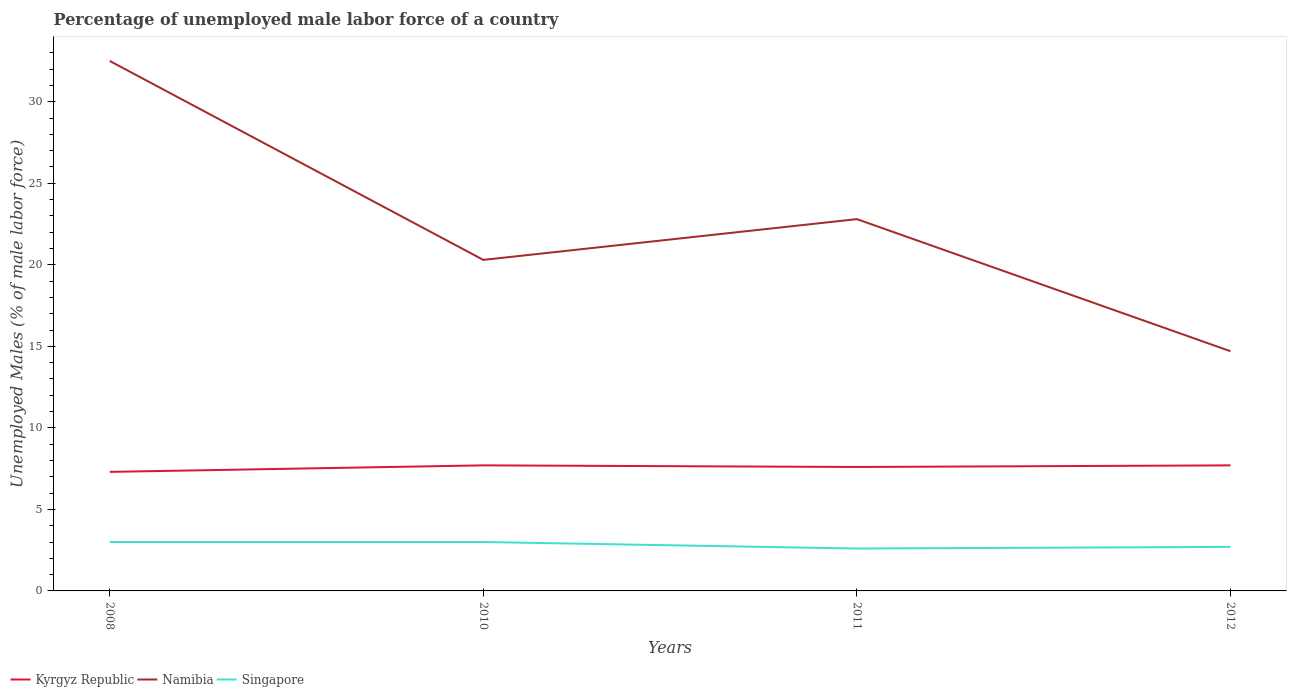Is the number of lines equal to the number of legend labels?
Your response must be concise. Yes. Across all years, what is the maximum percentage of unemployed male labor force in Kyrgyz Republic?
Give a very brief answer. 7.3. In which year was the percentage of unemployed male labor force in Namibia maximum?
Make the answer very short. 2012. What is the total percentage of unemployed male labor force in Namibia in the graph?
Give a very brief answer. -2.5. What is the difference between the highest and the second highest percentage of unemployed male labor force in Kyrgyz Republic?
Make the answer very short. 0.4. Is the percentage of unemployed male labor force in Kyrgyz Republic strictly greater than the percentage of unemployed male labor force in Namibia over the years?
Keep it short and to the point. Yes. How many years are there in the graph?
Ensure brevity in your answer.  4. Where does the legend appear in the graph?
Your response must be concise. Bottom left. How many legend labels are there?
Provide a succinct answer. 3. How are the legend labels stacked?
Keep it short and to the point. Horizontal. What is the title of the graph?
Give a very brief answer. Percentage of unemployed male labor force of a country. What is the label or title of the X-axis?
Offer a terse response. Years. What is the label or title of the Y-axis?
Your response must be concise. Unemployed Males (% of male labor force). What is the Unemployed Males (% of male labor force) in Kyrgyz Republic in 2008?
Make the answer very short. 7.3. What is the Unemployed Males (% of male labor force) of Namibia in 2008?
Your answer should be very brief. 32.5. What is the Unemployed Males (% of male labor force) of Singapore in 2008?
Make the answer very short. 3. What is the Unemployed Males (% of male labor force) of Kyrgyz Republic in 2010?
Provide a succinct answer. 7.7. What is the Unemployed Males (% of male labor force) in Namibia in 2010?
Provide a short and direct response. 20.3. What is the Unemployed Males (% of male labor force) in Kyrgyz Republic in 2011?
Provide a succinct answer. 7.6. What is the Unemployed Males (% of male labor force) of Namibia in 2011?
Offer a very short reply. 22.8. What is the Unemployed Males (% of male labor force) in Singapore in 2011?
Your answer should be very brief. 2.6. What is the Unemployed Males (% of male labor force) in Kyrgyz Republic in 2012?
Keep it short and to the point. 7.7. What is the Unemployed Males (% of male labor force) in Namibia in 2012?
Provide a short and direct response. 14.7. What is the Unemployed Males (% of male labor force) in Singapore in 2012?
Offer a very short reply. 2.7. Across all years, what is the maximum Unemployed Males (% of male labor force) of Kyrgyz Republic?
Ensure brevity in your answer.  7.7. Across all years, what is the maximum Unemployed Males (% of male labor force) of Namibia?
Offer a very short reply. 32.5. Across all years, what is the maximum Unemployed Males (% of male labor force) in Singapore?
Make the answer very short. 3. Across all years, what is the minimum Unemployed Males (% of male labor force) of Kyrgyz Republic?
Your answer should be compact. 7.3. Across all years, what is the minimum Unemployed Males (% of male labor force) in Namibia?
Give a very brief answer. 14.7. Across all years, what is the minimum Unemployed Males (% of male labor force) in Singapore?
Give a very brief answer. 2.6. What is the total Unemployed Males (% of male labor force) of Kyrgyz Republic in the graph?
Ensure brevity in your answer.  30.3. What is the total Unemployed Males (% of male labor force) in Namibia in the graph?
Your answer should be compact. 90.3. What is the total Unemployed Males (% of male labor force) of Singapore in the graph?
Ensure brevity in your answer.  11.3. What is the difference between the Unemployed Males (% of male labor force) of Kyrgyz Republic in 2008 and that in 2010?
Your response must be concise. -0.4. What is the difference between the Unemployed Males (% of male labor force) in Singapore in 2008 and that in 2011?
Give a very brief answer. 0.4. What is the difference between the Unemployed Males (% of male labor force) of Kyrgyz Republic in 2008 and that in 2012?
Make the answer very short. -0.4. What is the difference between the Unemployed Males (% of male labor force) of Singapore in 2008 and that in 2012?
Keep it short and to the point. 0.3. What is the difference between the Unemployed Males (% of male labor force) of Namibia in 2010 and that in 2011?
Your response must be concise. -2.5. What is the difference between the Unemployed Males (% of male labor force) in Kyrgyz Republic in 2010 and that in 2012?
Make the answer very short. 0. What is the difference between the Unemployed Males (% of male labor force) in Namibia in 2010 and that in 2012?
Offer a very short reply. 5.6. What is the difference between the Unemployed Males (% of male labor force) of Singapore in 2010 and that in 2012?
Your answer should be compact. 0.3. What is the difference between the Unemployed Males (% of male labor force) of Singapore in 2011 and that in 2012?
Provide a succinct answer. -0.1. What is the difference between the Unemployed Males (% of male labor force) of Kyrgyz Republic in 2008 and the Unemployed Males (% of male labor force) of Namibia in 2010?
Make the answer very short. -13. What is the difference between the Unemployed Males (% of male labor force) of Kyrgyz Republic in 2008 and the Unemployed Males (% of male labor force) of Singapore in 2010?
Provide a short and direct response. 4.3. What is the difference between the Unemployed Males (% of male labor force) of Namibia in 2008 and the Unemployed Males (% of male labor force) of Singapore in 2010?
Your response must be concise. 29.5. What is the difference between the Unemployed Males (% of male labor force) of Kyrgyz Republic in 2008 and the Unemployed Males (% of male labor force) of Namibia in 2011?
Keep it short and to the point. -15.5. What is the difference between the Unemployed Males (% of male labor force) of Namibia in 2008 and the Unemployed Males (% of male labor force) of Singapore in 2011?
Keep it short and to the point. 29.9. What is the difference between the Unemployed Males (% of male labor force) of Kyrgyz Republic in 2008 and the Unemployed Males (% of male labor force) of Namibia in 2012?
Your answer should be compact. -7.4. What is the difference between the Unemployed Males (% of male labor force) in Kyrgyz Republic in 2008 and the Unemployed Males (% of male labor force) in Singapore in 2012?
Your answer should be compact. 4.6. What is the difference between the Unemployed Males (% of male labor force) of Namibia in 2008 and the Unemployed Males (% of male labor force) of Singapore in 2012?
Your response must be concise. 29.8. What is the difference between the Unemployed Males (% of male labor force) in Kyrgyz Republic in 2010 and the Unemployed Males (% of male labor force) in Namibia in 2011?
Offer a terse response. -15.1. What is the difference between the Unemployed Males (% of male labor force) in Kyrgyz Republic in 2010 and the Unemployed Males (% of male labor force) in Singapore in 2012?
Make the answer very short. 5. What is the difference between the Unemployed Males (% of male labor force) of Namibia in 2010 and the Unemployed Males (% of male labor force) of Singapore in 2012?
Ensure brevity in your answer.  17.6. What is the difference between the Unemployed Males (% of male labor force) in Kyrgyz Republic in 2011 and the Unemployed Males (% of male labor force) in Namibia in 2012?
Make the answer very short. -7.1. What is the difference between the Unemployed Males (% of male labor force) in Namibia in 2011 and the Unemployed Males (% of male labor force) in Singapore in 2012?
Ensure brevity in your answer.  20.1. What is the average Unemployed Males (% of male labor force) in Kyrgyz Republic per year?
Provide a short and direct response. 7.58. What is the average Unemployed Males (% of male labor force) in Namibia per year?
Your response must be concise. 22.57. What is the average Unemployed Males (% of male labor force) in Singapore per year?
Provide a short and direct response. 2.83. In the year 2008, what is the difference between the Unemployed Males (% of male labor force) of Kyrgyz Republic and Unemployed Males (% of male labor force) of Namibia?
Your answer should be compact. -25.2. In the year 2008, what is the difference between the Unemployed Males (% of male labor force) of Kyrgyz Republic and Unemployed Males (% of male labor force) of Singapore?
Keep it short and to the point. 4.3. In the year 2008, what is the difference between the Unemployed Males (% of male labor force) in Namibia and Unemployed Males (% of male labor force) in Singapore?
Give a very brief answer. 29.5. In the year 2010, what is the difference between the Unemployed Males (% of male labor force) of Kyrgyz Republic and Unemployed Males (% of male labor force) of Namibia?
Provide a succinct answer. -12.6. In the year 2011, what is the difference between the Unemployed Males (% of male labor force) of Kyrgyz Republic and Unemployed Males (% of male labor force) of Namibia?
Give a very brief answer. -15.2. In the year 2011, what is the difference between the Unemployed Males (% of male labor force) of Namibia and Unemployed Males (% of male labor force) of Singapore?
Offer a terse response. 20.2. In the year 2012, what is the difference between the Unemployed Males (% of male labor force) in Kyrgyz Republic and Unemployed Males (% of male labor force) in Singapore?
Keep it short and to the point. 5. In the year 2012, what is the difference between the Unemployed Males (% of male labor force) of Namibia and Unemployed Males (% of male labor force) of Singapore?
Your answer should be very brief. 12. What is the ratio of the Unemployed Males (% of male labor force) of Kyrgyz Republic in 2008 to that in 2010?
Ensure brevity in your answer.  0.95. What is the ratio of the Unemployed Males (% of male labor force) in Namibia in 2008 to that in 2010?
Give a very brief answer. 1.6. What is the ratio of the Unemployed Males (% of male labor force) in Kyrgyz Republic in 2008 to that in 2011?
Offer a terse response. 0.96. What is the ratio of the Unemployed Males (% of male labor force) in Namibia in 2008 to that in 2011?
Make the answer very short. 1.43. What is the ratio of the Unemployed Males (% of male labor force) of Singapore in 2008 to that in 2011?
Your answer should be very brief. 1.15. What is the ratio of the Unemployed Males (% of male labor force) of Kyrgyz Republic in 2008 to that in 2012?
Your answer should be compact. 0.95. What is the ratio of the Unemployed Males (% of male labor force) of Namibia in 2008 to that in 2012?
Make the answer very short. 2.21. What is the ratio of the Unemployed Males (% of male labor force) of Singapore in 2008 to that in 2012?
Make the answer very short. 1.11. What is the ratio of the Unemployed Males (% of male labor force) in Kyrgyz Republic in 2010 to that in 2011?
Keep it short and to the point. 1.01. What is the ratio of the Unemployed Males (% of male labor force) of Namibia in 2010 to that in 2011?
Give a very brief answer. 0.89. What is the ratio of the Unemployed Males (% of male labor force) of Singapore in 2010 to that in 2011?
Offer a very short reply. 1.15. What is the ratio of the Unemployed Males (% of male labor force) in Kyrgyz Republic in 2010 to that in 2012?
Offer a very short reply. 1. What is the ratio of the Unemployed Males (% of male labor force) of Namibia in 2010 to that in 2012?
Offer a terse response. 1.38. What is the ratio of the Unemployed Males (% of male labor force) of Kyrgyz Republic in 2011 to that in 2012?
Keep it short and to the point. 0.99. What is the ratio of the Unemployed Males (% of male labor force) in Namibia in 2011 to that in 2012?
Your response must be concise. 1.55. What is the difference between the highest and the second highest Unemployed Males (% of male labor force) in Namibia?
Offer a very short reply. 9.7. What is the difference between the highest and the second highest Unemployed Males (% of male labor force) in Singapore?
Keep it short and to the point. 0. What is the difference between the highest and the lowest Unemployed Males (% of male labor force) of Kyrgyz Republic?
Make the answer very short. 0.4. 